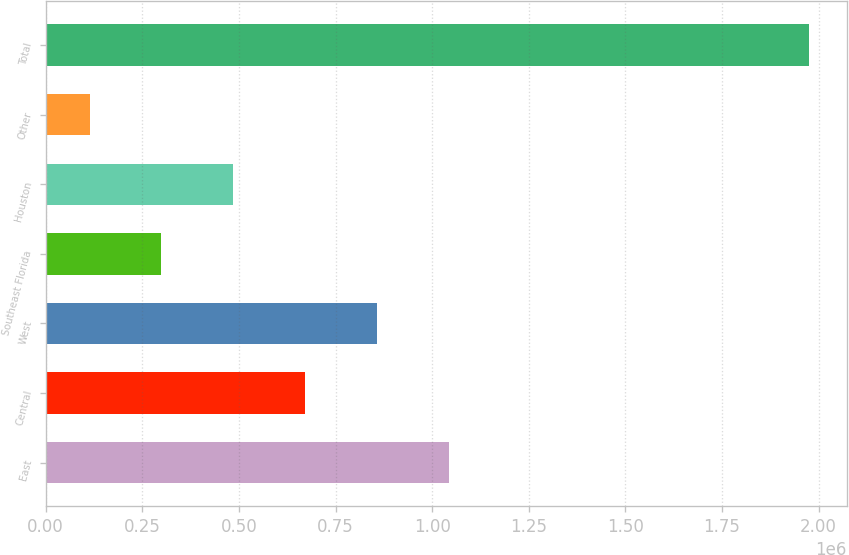Convert chart to OTSL. <chart><loc_0><loc_0><loc_500><loc_500><bar_chart><fcel>East<fcel>Central<fcel>West<fcel>Southeast Florida<fcel>Houston<fcel>Other<fcel>Total<nl><fcel>1.04395e+06<fcel>671792<fcel>857869<fcel>299640<fcel>485716<fcel>113563<fcel>1.97433e+06<nl></chart> 